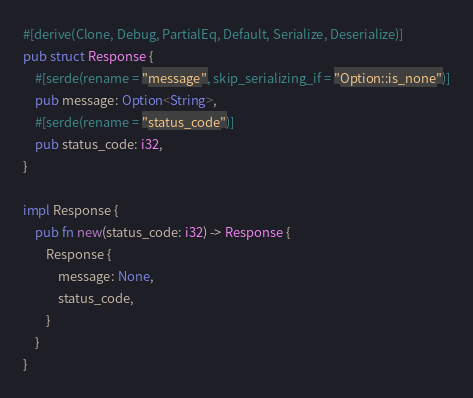Convert code to text. <code><loc_0><loc_0><loc_500><loc_500><_Rust_>
#[derive(Clone, Debug, PartialEq, Default, Serialize, Deserialize)]
pub struct Response {
    #[serde(rename = "message", skip_serializing_if = "Option::is_none")]
    pub message: Option<String>,
    #[serde(rename = "status_code")]
    pub status_code: i32,
}

impl Response {
    pub fn new(status_code: i32) -> Response {
        Response {
            message: None,
            status_code,
        }
    }
}


</code> 